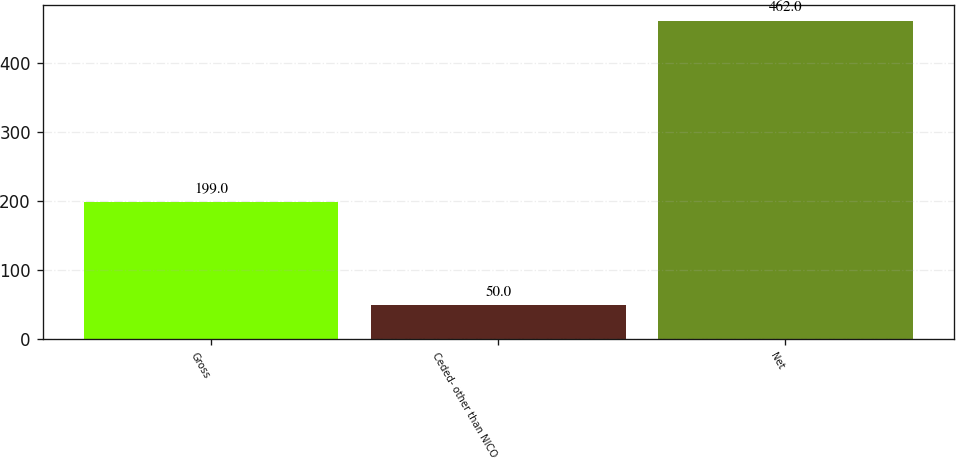Convert chart. <chart><loc_0><loc_0><loc_500><loc_500><bar_chart><fcel>Gross<fcel>Ceded- other than NICO<fcel>Net<nl><fcel>199<fcel>50<fcel>462<nl></chart> 